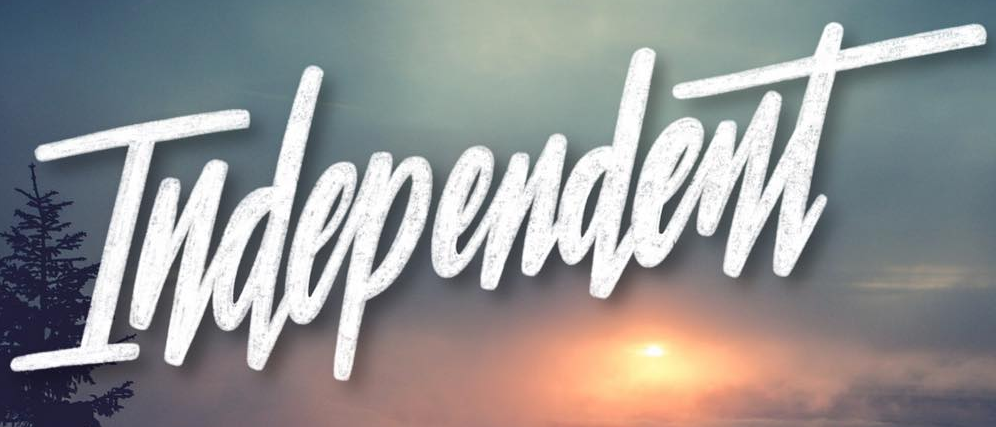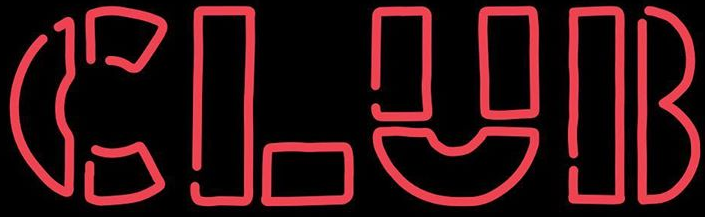Transcribe the words shown in these images in order, separated by a semicolon. Independent; CLUB 